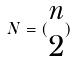<formula> <loc_0><loc_0><loc_500><loc_500>N = ( \begin{matrix} n \\ 2 \end{matrix} )</formula> 